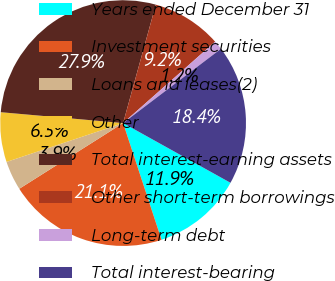Convert chart. <chart><loc_0><loc_0><loc_500><loc_500><pie_chart><fcel>Years ended December 31<fcel>Investment securities<fcel>Loans and leases(2)<fcel>Other<fcel>Total interest-earning assets<fcel>Other short-term borrowings<fcel>Long-term debt<fcel>Total interest-bearing<nl><fcel>11.86%<fcel>21.08%<fcel>3.86%<fcel>6.53%<fcel>27.87%<fcel>9.19%<fcel>1.19%<fcel>18.41%<nl></chart> 